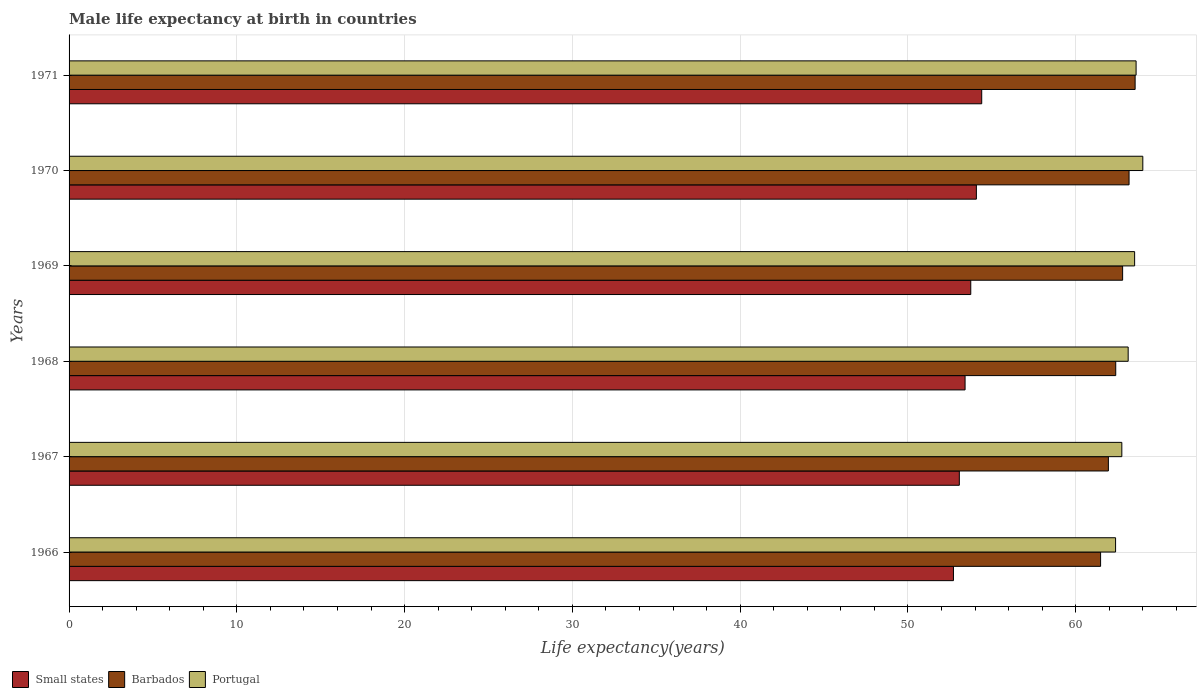How many different coloured bars are there?
Give a very brief answer. 3. How many groups of bars are there?
Offer a very short reply. 6. Are the number of bars per tick equal to the number of legend labels?
Provide a succinct answer. Yes. How many bars are there on the 3rd tick from the top?
Give a very brief answer. 3. How many bars are there on the 4th tick from the bottom?
Make the answer very short. 3. What is the label of the 1st group of bars from the top?
Give a very brief answer. 1971. What is the male life expectancy at birth in Small states in 1967?
Your answer should be very brief. 53.06. Across all years, what is the minimum male life expectancy at birth in Portugal?
Provide a short and direct response. 62.38. In which year was the male life expectancy at birth in Portugal maximum?
Provide a short and direct response. 1970. In which year was the male life expectancy at birth in Portugal minimum?
Offer a very short reply. 1966. What is the total male life expectancy at birth in Barbados in the graph?
Your answer should be compact. 375.34. What is the difference between the male life expectancy at birth in Portugal in 1967 and that in 1971?
Your answer should be compact. -0.85. What is the difference between the male life expectancy at birth in Portugal in 1966 and the male life expectancy at birth in Barbados in 1971?
Your answer should be very brief. -1.16. What is the average male life expectancy at birth in Small states per year?
Keep it short and to the point. 53.57. In the year 1969, what is the difference between the male life expectancy at birth in Barbados and male life expectancy at birth in Portugal?
Offer a very short reply. -0.72. What is the ratio of the male life expectancy at birth in Portugal in 1966 to that in 1970?
Give a very brief answer. 0.97. Is the male life expectancy at birth in Barbados in 1967 less than that in 1970?
Offer a very short reply. Yes. What is the difference between the highest and the second highest male life expectancy at birth in Portugal?
Your answer should be very brief. 0.4. What is the difference between the highest and the lowest male life expectancy at birth in Portugal?
Provide a short and direct response. 1.62. What does the 2nd bar from the bottom in 1969 represents?
Provide a succinct answer. Barbados. Is it the case that in every year, the sum of the male life expectancy at birth in Small states and male life expectancy at birth in Barbados is greater than the male life expectancy at birth in Portugal?
Offer a very short reply. Yes. What is the difference between two consecutive major ticks on the X-axis?
Make the answer very short. 10. Are the values on the major ticks of X-axis written in scientific E-notation?
Provide a short and direct response. No. Where does the legend appear in the graph?
Your answer should be very brief. Bottom left. What is the title of the graph?
Ensure brevity in your answer.  Male life expectancy at birth in countries. What is the label or title of the X-axis?
Your response must be concise. Life expectancy(years). What is the Life expectancy(years) of Small states in 1966?
Offer a terse response. 52.71. What is the Life expectancy(years) in Barbados in 1966?
Make the answer very short. 61.48. What is the Life expectancy(years) in Portugal in 1966?
Your response must be concise. 62.38. What is the Life expectancy(years) of Small states in 1967?
Provide a short and direct response. 53.06. What is the Life expectancy(years) of Barbados in 1967?
Keep it short and to the point. 61.95. What is the Life expectancy(years) of Portugal in 1967?
Give a very brief answer. 62.75. What is the Life expectancy(years) of Small states in 1968?
Offer a terse response. 53.41. What is the Life expectancy(years) in Barbados in 1968?
Give a very brief answer. 62.39. What is the Life expectancy(years) of Portugal in 1968?
Offer a terse response. 63.13. What is the Life expectancy(years) in Small states in 1969?
Give a very brief answer. 53.75. What is the Life expectancy(years) in Barbados in 1969?
Your answer should be compact. 62.8. What is the Life expectancy(years) in Portugal in 1969?
Make the answer very short. 63.51. What is the Life expectancy(years) of Small states in 1970?
Keep it short and to the point. 54.08. What is the Life expectancy(years) in Barbados in 1970?
Provide a succinct answer. 63.18. What is the Life expectancy(years) in Portugal in 1970?
Offer a very short reply. 64. What is the Life expectancy(years) of Small states in 1971?
Your answer should be compact. 54.4. What is the Life expectancy(years) of Barbados in 1971?
Keep it short and to the point. 63.54. What is the Life expectancy(years) in Portugal in 1971?
Your answer should be very brief. 63.6. Across all years, what is the maximum Life expectancy(years) of Small states?
Offer a terse response. 54.4. Across all years, what is the maximum Life expectancy(years) of Barbados?
Ensure brevity in your answer.  63.54. Across all years, what is the minimum Life expectancy(years) of Small states?
Provide a succinct answer. 52.71. Across all years, what is the minimum Life expectancy(years) in Barbados?
Provide a succinct answer. 61.48. Across all years, what is the minimum Life expectancy(years) in Portugal?
Make the answer very short. 62.38. What is the total Life expectancy(years) of Small states in the graph?
Provide a succinct answer. 321.41. What is the total Life expectancy(years) of Barbados in the graph?
Give a very brief answer. 375.34. What is the total Life expectancy(years) in Portugal in the graph?
Provide a succinct answer. 379.37. What is the difference between the Life expectancy(years) of Small states in 1966 and that in 1967?
Offer a very short reply. -0.35. What is the difference between the Life expectancy(years) in Barbados in 1966 and that in 1967?
Ensure brevity in your answer.  -0.46. What is the difference between the Life expectancy(years) of Portugal in 1966 and that in 1967?
Offer a very short reply. -0.37. What is the difference between the Life expectancy(years) in Small states in 1966 and that in 1968?
Your answer should be compact. -0.69. What is the difference between the Life expectancy(years) in Barbados in 1966 and that in 1968?
Make the answer very short. -0.9. What is the difference between the Life expectancy(years) of Portugal in 1966 and that in 1968?
Make the answer very short. -0.75. What is the difference between the Life expectancy(years) in Small states in 1966 and that in 1969?
Your response must be concise. -1.03. What is the difference between the Life expectancy(years) of Barbados in 1966 and that in 1969?
Your answer should be very brief. -1.31. What is the difference between the Life expectancy(years) in Portugal in 1966 and that in 1969?
Provide a short and direct response. -1.14. What is the difference between the Life expectancy(years) in Small states in 1966 and that in 1970?
Offer a very short reply. -1.37. What is the difference between the Life expectancy(years) of Barbados in 1966 and that in 1970?
Make the answer very short. -1.7. What is the difference between the Life expectancy(years) of Portugal in 1966 and that in 1970?
Make the answer very short. -1.62. What is the difference between the Life expectancy(years) in Small states in 1966 and that in 1971?
Your response must be concise. -1.68. What is the difference between the Life expectancy(years) in Barbados in 1966 and that in 1971?
Your response must be concise. -2.06. What is the difference between the Life expectancy(years) in Portugal in 1966 and that in 1971?
Ensure brevity in your answer.  -1.22. What is the difference between the Life expectancy(years) of Small states in 1967 and that in 1968?
Your response must be concise. -0.34. What is the difference between the Life expectancy(years) in Barbados in 1967 and that in 1968?
Your answer should be compact. -0.44. What is the difference between the Life expectancy(years) of Portugal in 1967 and that in 1968?
Your answer should be compact. -0.38. What is the difference between the Life expectancy(years) in Small states in 1967 and that in 1969?
Provide a short and direct response. -0.68. What is the difference between the Life expectancy(years) of Barbados in 1967 and that in 1969?
Your answer should be compact. -0.85. What is the difference between the Life expectancy(years) of Portugal in 1967 and that in 1969?
Your answer should be compact. -0.76. What is the difference between the Life expectancy(years) in Small states in 1967 and that in 1970?
Provide a succinct answer. -1.02. What is the difference between the Life expectancy(years) in Barbados in 1967 and that in 1970?
Make the answer very short. -1.23. What is the difference between the Life expectancy(years) in Portugal in 1967 and that in 1970?
Offer a very short reply. -1.25. What is the difference between the Life expectancy(years) of Small states in 1967 and that in 1971?
Offer a very short reply. -1.33. What is the difference between the Life expectancy(years) in Barbados in 1967 and that in 1971?
Your response must be concise. -1.59. What is the difference between the Life expectancy(years) of Portugal in 1967 and that in 1971?
Make the answer very short. -0.85. What is the difference between the Life expectancy(years) of Small states in 1968 and that in 1969?
Offer a terse response. -0.34. What is the difference between the Life expectancy(years) of Barbados in 1968 and that in 1969?
Provide a short and direct response. -0.41. What is the difference between the Life expectancy(years) in Portugal in 1968 and that in 1969?
Ensure brevity in your answer.  -0.38. What is the difference between the Life expectancy(years) of Small states in 1968 and that in 1970?
Your answer should be compact. -0.67. What is the difference between the Life expectancy(years) of Barbados in 1968 and that in 1970?
Your response must be concise. -0.8. What is the difference between the Life expectancy(years) of Portugal in 1968 and that in 1970?
Provide a succinct answer. -0.87. What is the difference between the Life expectancy(years) in Small states in 1968 and that in 1971?
Offer a terse response. -0.99. What is the difference between the Life expectancy(years) in Barbados in 1968 and that in 1971?
Provide a succinct answer. -1.16. What is the difference between the Life expectancy(years) of Portugal in 1968 and that in 1971?
Your answer should be compact. -0.47. What is the difference between the Life expectancy(years) in Small states in 1969 and that in 1970?
Your response must be concise. -0.33. What is the difference between the Life expectancy(years) of Barbados in 1969 and that in 1970?
Your answer should be compact. -0.38. What is the difference between the Life expectancy(years) of Portugal in 1969 and that in 1970?
Make the answer very short. -0.49. What is the difference between the Life expectancy(years) of Small states in 1969 and that in 1971?
Give a very brief answer. -0.65. What is the difference between the Life expectancy(years) in Barbados in 1969 and that in 1971?
Your response must be concise. -0.74. What is the difference between the Life expectancy(years) in Portugal in 1969 and that in 1971?
Keep it short and to the point. -0.09. What is the difference between the Life expectancy(years) in Small states in 1970 and that in 1971?
Keep it short and to the point. -0.32. What is the difference between the Life expectancy(years) in Barbados in 1970 and that in 1971?
Keep it short and to the point. -0.36. What is the difference between the Life expectancy(years) of Small states in 1966 and the Life expectancy(years) of Barbados in 1967?
Your response must be concise. -9.23. What is the difference between the Life expectancy(years) in Small states in 1966 and the Life expectancy(years) in Portugal in 1967?
Provide a short and direct response. -10.04. What is the difference between the Life expectancy(years) in Barbados in 1966 and the Life expectancy(years) in Portugal in 1967?
Ensure brevity in your answer.  -1.27. What is the difference between the Life expectancy(years) of Small states in 1966 and the Life expectancy(years) of Barbados in 1968?
Give a very brief answer. -9.67. What is the difference between the Life expectancy(years) in Small states in 1966 and the Life expectancy(years) in Portugal in 1968?
Your answer should be compact. -10.41. What is the difference between the Life expectancy(years) in Barbados in 1966 and the Life expectancy(years) in Portugal in 1968?
Give a very brief answer. -1.64. What is the difference between the Life expectancy(years) in Small states in 1966 and the Life expectancy(years) in Barbados in 1969?
Offer a very short reply. -10.08. What is the difference between the Life expectancy(years) in Small states in 1966 and the Life expectancy(years) in Portugal in 1969?
Provide a succinct answer. -10.8. What is the difference between the Life expectancy(years) of Barbados in 1966 and the Life expectancy(years) of Portugal in 1969?
Keep it short and to the point. -2.03. What is the difference between the Life expectancy(years) in Small states in 1966 and the Life expectancy(years) in Barbados in 1970?
Offer a very short reply. -10.47. What is the difference between the Life expectancy(years) in Small states in 1966 and the Life expectancy(years) in Portugal in 1970?
Your response must be concise. -11.29. What is the difference between the Life expectancy(years) of Barbados in 1966 and the Life expectancy(years) of Portugal in 1970?
Offer a very short reply. -2.52. What is the difference between the Life expectancy(years) in Small states in 1966 and the Life expectancy(years) in Barbados in 1971?
Offer a very short reply. -10.83. What is the difference between the Life expectancy(years) in Small states in 1966 and the Life expectancy(years) in Portugal in 1971?
Your response must be concise. -10.89. What is the difference between the Life expectancy(years) in Barbados in 1966 and the Life expectancy(years) in Portugal in 1971?
Provide a succinct answer. -2.12. What is the difference between the Life expectancy(years) in Small states in 1967 and the Life expectancy(years) in Barbados in 1968?
Your response must be concise. -9.32. What is the difference between the Life expectancy(years) in Small states in 1967 and the Life expectancy(years) in Portugal in 1968?
Make the answer very short. -10.06. What is the difference between the Life expectancy(years) in Barbados in 1967 and the Life expectancy(years) in Portugal in 1968?
Your response must be concise. -1.18. What is the difference between the Life expectancy(years) in Small states in 1967 and the Life expectancy(years) in Barbados in 1969?
Provide a short and direct response. -9.73. What is the difference between the Life expectancy(years) of Small states in 1967 and the Life expectancy(years) of Portugal in 1969?
Offer a very short reply. -10.45. What is the difference between the Life expectancy(years) of Barbados in 1967 and the Life expectancy(years) of Portugal in 1969?
Make the answer very short. -1.56. What is the difference between the Life expectancy(years) of Small states in 1967 and the Life expectancy(years) of Barbados in 1970?
Your answer should be compact. -10.12. What is the difference between the Life expectancy(years) of Small states in 1967 and the Life expectancy(years) of Portugal in 1970?
Your answer should be very brief. -10.94. What is the difference between the Life expectancy(years) in Barbados in 1967 and the Life expectancy(years) in Portugal in 1970?
Give a very brief answer. -2.05. What is the difference between the Life expectancy(years) of Small states in 1967 and the Life expectancy(years) of Barbados in 1971?
Your answer should be compact. -10.48. What is the difference between the Life expectancy(years) in Small states in 1967 and the Life expectancy(years) in Portugal in 1971?
Ensure brevity in your answer.  -10.54. What is the difference between the Life expectancy(years) of Barbados in 1967 and the Life expectancy(years) of Portugal in 1971?
Your answer should be compact. -1.65. What is the difference between the Life expectancy(years) in Small states in 1968 and the Life expectancy(years) in Barbados in 1969?
Provide a succinct answer. -9.39. What is the difference between the Life expectancy(years) of Small states in 1968 and the Life expectancy(years) of Portugal in 1969?
Ensure brevity in your answer.  -10.11. What is the difference between the Life expectancy(years) of Barbados in 1968 and the Life expectancy(years) of Portugal in 1969?
Provide a succinct answer. -1.13. What is the difference between the Life expectancy(years) of Small states in 1968 and the Life expectancy(years) of Barbados in 1970?
Offer a terse response. -9.77. What is the difference between the Life expectancy(years) in Small states in 1968 and the Life expectancy(years) in Portugal in 1970?
Offer a very short reply. -10.59. What is the difference between the Life expectancy(years) in Barbados in 1968 and the Life expectancy(years) in Portugal in 1970?
Provide a succinct answer. -1.61. What is the difference between the Life expectancy(years) in Small states in 1968 and the Life expectancy(years) in Barbados in 1971?
Your answer should be compact. -10.14. What is the difference between the Life expectancy(years) in Small states in 1968 and the Life expectancy(years) in Portugal in 1971?
Your answer should be compact. -10.19. What is the difference between the Life expectancy(years) of Barbados in 1968 and the Life expectancy(years) of Portugal in 1971?
Your response must be concise. -1.21. What is the difference between the Life expectancy(years) of Small states in 1969 and the Life expectancy(years) of Barbados in 1970?
Offer a very short reply. -9.44. What is the difference between the Life expectancy(years) of Small states in 1969 and the Life expectancy(years) of Portugal in 1970?
Provide a short and direct response. -10.25. What is the difference between the Life expectancy(years) of Barbados in 1969 and the Life expectancy(years) of Portugal in 1970?
Your response must be concise. -1.2. What is the difference between the Life expectancy(years) in Small states in 1969 and the Life expectancy(years) in Barbados in 1971?
Your answer should be compact. -9.8. What is the difference between the Life expectancy(years) in Small states in 1969 and the Life expectancy(years) in Portugal in 1971?
Give a very brief answer. -9.85. What is the difference between the Life expectancy(years) in Barbados in 1969 and the Life expectancy(years) in Portugal in 1971?
Give a very brief answer. -0.8. What is the difference between the Life expectancy(years) in Small states in 1970 and the Life expectancy(years) in Barbados in 1971?
Your answer should be compact. -9.46. What is the difference between the Life expectancy(years) of Small states in 1970 and the Life expectancy(years) of Portugal in 1971?
Your answer should be compact. -9.52. What is the difference between the Life expectancy(years) of Barbados in 1970 and the Life expectancy(years) of Portugal in 1971?
Your response must be concise. -0.42. What is the average Life expectancy(years) in Small states per year?
Ensure brevity in your answer.  53.57. What is the average Life expectancy(years) of Barbados per year?
Ensure brevity in your answer.  62.56. What is the average Life expectancy(years) of Portugal per year?
Offer a very short reply. 63.23. In the year 1966, what is the difference between the Life expectancy(years) of Small states and Life expectancy(years) of Barbados?
Your response must be concise. -8.77. In the year 1966, what is the difference between the Life expectancy(years) of Small states and Life expectancy(years) of Portugal?
Offer a very short reply. -9.66. In the year 1966, what is the difference between the Life expectancy(years) in Barbados and Life expectancy(years) in Portugal?
Offer a very short reply. -0.89. In the year 1967, what is the difference between the Life expectancy(years) in Small states and Life expectancy(years) in Barbados?
Your response must be concise. -8.88. In the year 1967, what is the difference between the Life expectancy(years) in Small states and Life expectancy(years) in Portugal?
Give a very brief answer. -9.69. In the year 1967, what is the difference between the Life expectancy(years) of Barbados and Life expectancy(years) of Portugal?
Offer a very short reply. -0.8. In the year 1968, what is the difference between the Life expectancy(years) in Small states and Life expectancy(years) in Barbados?
Give a very brief answer. -8.98. In the year 1968, what is the difference between the Life expectancy(years) of Small states and Life expectancy(years) of Portugal?
Provide a succinct answer. -9.72. In the year 1968, what is the difference between the Life expectancy(years) in Barbados and Life expectancy(years) in Portugal?
Your answer should be very brief. -0.74. In the year 1969, what is the difference between the Life expectancy(years) in Small states and Life expectancy(years) in Barbados?
Make the answer very short. -9.05. In the year 1969, what is the difference between the Life expectancy(years) of Small states and Life expectancy(years) of Portugal?
Offer a very short reply. -9.77. In the year 1969, what is the difference between the Life expectancy(years) in Barbados and Life expectancy(years) in Portugal?
Your answer should be very brief. -0.71. In the year 1970, what is the difference between the Life expectancy(years) of Small states and Life expectancy(years) of Barbados?
Your answer should be compact. -9.1. In the year 1970, what is the difference between the Life expectancy(years) of Small states and Life expectancy(years) of Portugal?
Your answer should be compact. -9.92. In the year 1970, what is the difference between the Life expectancy(years) of Barbados and Life expectancy(years) of Portugal?
Make the answer very short. -0.82. In the year 1971, what is the difference between the Life expectancy(years) of Small states and Life expectancy(years) of Barbados?
Your answer should be compact. -9.14. In the year 1971, what is the difference between the Life expectancy(years) in Small states and Life expectancy(years) in Portugal?
Your response must be concise. -9.2. In the year 1971, what is the difference between the Life expectancy(years) of Barbados and Life expectancy(years) of Portugal?
Make the answer very short. -0.06. What is the ratio of the Life expectancy(years) in Barbados in 1966 to that in 1967?
Give a very brief answer. 0.99. What is the ratio of the Life expectancy(years) of Small states in 1966 to that in 1968?
Your answer should be compact. 0.99. What is the ratio of the Life expectancy(years) of Barbados in 1966 to that in 1968?
Your answer should be compact. 0.99. What is the ratio of the Life expectancy(years) in Small states in 1966 to that in 1969?
Provide a succinct answer. 0.98. What is the ratio of the Life expectancy(years) of Barbados in 1966 to that in 1969?
Your answer should be very brief. 0.98. What is the ratio of the Life expectancy(years) in Portugal in 1966 to that in 1969?
Provide a short and direct response. 0.98. What is the ratio of the Life expectancy(years) of Small states in 1966 to that in 1970?
Your answer should be compact. 0.97. What is the ratio of the Life expectancy(years) of Barbados in 1966 to that in 1970?
Make the answer very short. 0.97. What is the ratio of the Life expectancy(years) in Portugal in 1966 to that in 1970?
Provide a short and direct response. 0.97. What is the ratio of the Life expectancy(years) of Small states in 1966 to that in 1971?
Ensure brevity in your answer.  0.97. What is the ratio of the Life expectancy(years) in Barbados in 1966 to that in 1971?
Ensure brevity in your answer.  0.97. What is the ratio of the Life expectancy(years) of Portugal in 1966 to that in 1971?
Keep it short and to the point. 0.98. What is the ratio of the Life expectancy(years) of Small states in 1967 to that in 1968?
Your answer should be compact. 0.99. What is the ratio of the Life expectancy(years) in Barbados in 1967 to that in 1968?
Your response must be concise. 0.99. What is the ratio of the Life expectancy(years) of Portugal in 1967 to that in 1968?
Offer a very short reply. 0.99. What is the ratio of the Life expectancy(years) in Small states in 1967 to that in 1969?
Give a very brief answer. 0.99. What is the ratio of the Life expectancy(years) in Barbados in 1967 to that in 1969?
Ensure brevity in your answer.  0.99. What is the ratio of the Life expectancy(years) of Portugal in 1967 to that in 1969?
Provide a short and direct response. 0.99. What is the ratio of the Life expectancy(years) of Small states in 1967 to that in 1970?
Give a very brief answer. 0.98. What is the ratio of the Life expectancy(years) of Barbados in 1967 to that in 1970?
Offer a terse response. 0.98. What is the ratio of the Life expectancy(years) in Portugal in 1967 to that in 1970?
Your response must be concise. 0.98. What is the ratio of the Life expectancy(years) in Small states in 1967 to that in 1971?
Your answer should be compact. 0.98. What is the ratio of the Life expectancy(years) in Barbados in 1967 to that in 1971?
Your answer should be very brief. 0.97. What is the ratio of the Life expectancy(years) of Portugal in 1967 to that in 1971?
Your answer should be very brief. 0.99. What is the ratio of the Life expectancy(years) in Small states in 1968 to that in 1969?
Make the answer very short. 0.99. What is the ratio of the Life expectancy(years) in Portugal in 1968 to that in 1969?
Your response must be concise. 0.99. What is the ratio of the Life expectancy(years) in Small states in 1968 to that in 1970?
Keep it short and to the point. 0.99. What is the ratio of the Life expectancy(years) of Barbados in 1968 to that in 1970?
Offer a very short reply. 0.99. What is the ratio of the Life expectancy(years) of Portugal in 1968 to that in 1970?
Ensure brevity in your answer.  0.99. What is the ratio of the Life expectancy(years) of Small states in 1968 to that in 1971?
Offer a terse response. 0.98. What is the ratio of the Life expectancy(years) of Barbados in 1968 to that in 1971?
Give a very brief answer. 0.98. What is the ratio of the Life expectancy(years) in Portugal in 1968 to that in 1971?
Offer a terse response. 0.99. What is the ratio of the Life expectancy(years) in Small states in 1969 to that in 1970?
Keep it short and to the point. 0.99. What is the ratio of the Life expectancy(years) in Barbados in 1969 to that in 1971?
Make the answer very short. 0.99. What is the ratio of the Life expectancy(years) of Portugal in 1969 to that in 1971?
Ensure brevity in your answer.  1. What is the ratio of the Life expectancy(years) in Barbados in 1970 to that in 1971?
Your answer should be very brief. 0.99. What is the difference between the highest and the second highest Life expectancy(years) of Small states?
Your answer should be very brief. 0.32. What is the difference between the highest and the second highest Life expectancy(years) in Barbados?
Your answer should be very brief. 0.36. What is the difference between the highest and the second highest Life expectancy(years) in Portugal?
Give a very brief answer. 0.4. What is the difference between the highest and the lowest Life expectancy(years) in Small states?
Make the answer very short. 1.68. What is the difference between the highest and the lowest Life expectancy(years) of Barbados?
Keep it short and to the point. 2.06. What is the difference between the highest and the lowest Life expectancy(years) of Portugal?
Your answer should be very brief. 1.62. 